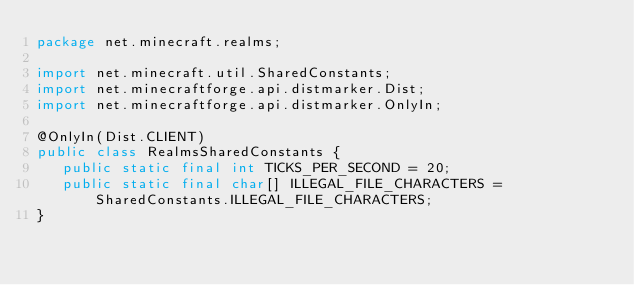Convert code to text. <code><loc_0><loc_0><loc_500><loc_500><_Java_>package net.minecraft.realms;

import net.minecraft.util.SharedConstants;
import net.minecraftforge.api.distmarker.Dist;
import net.minecraftforge.api.distmarker.OnlyIn;

@OnlyIn(Dist.CLIENT)
public class RealmsSharedConstants {
   public static final int TICKS_PER_SECOND = 20;
   public static final char[] ILLEGAL_FILE_CHARACTERS = SharedConstants.ILLEGAL_FILE_CHARACTERS;
}</code> 